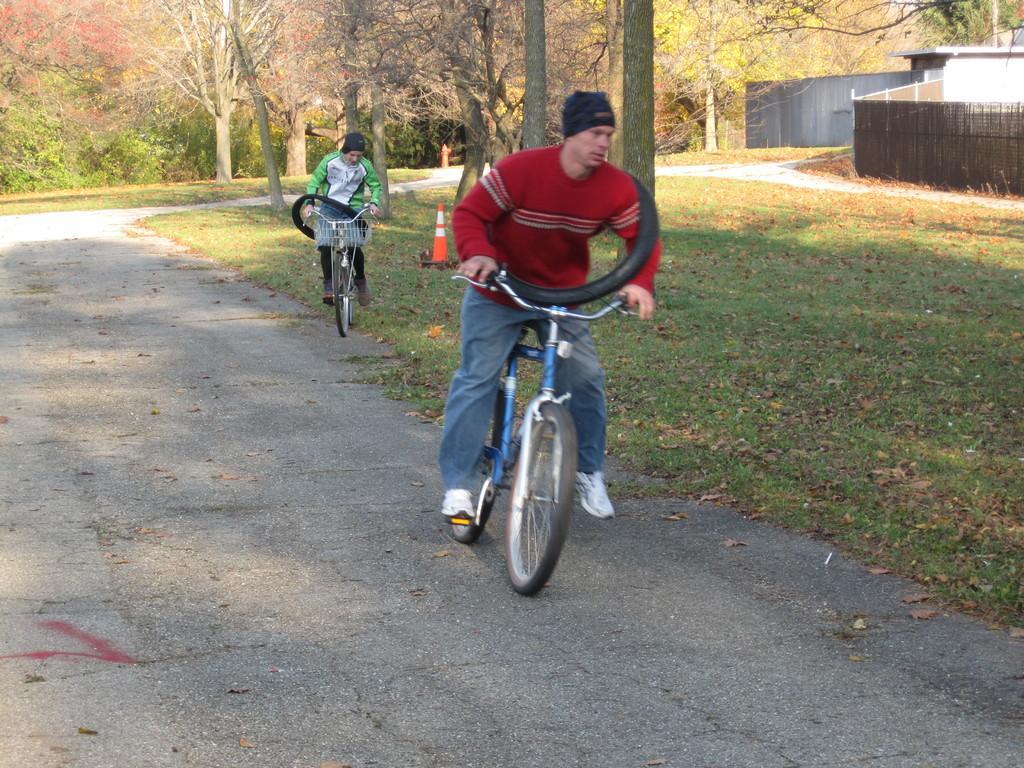Please provide a concise description of this image. It's a sunny day the picture is taken outside on the road where two people are riding their bicycles, first person is wearing a red shirt and holding a tyre and behind him there is a woman in green dress wearing tyre on her wrist behind them there are number of trees and one house at the right corner of the picture. Behind the person there are traffic cones. 